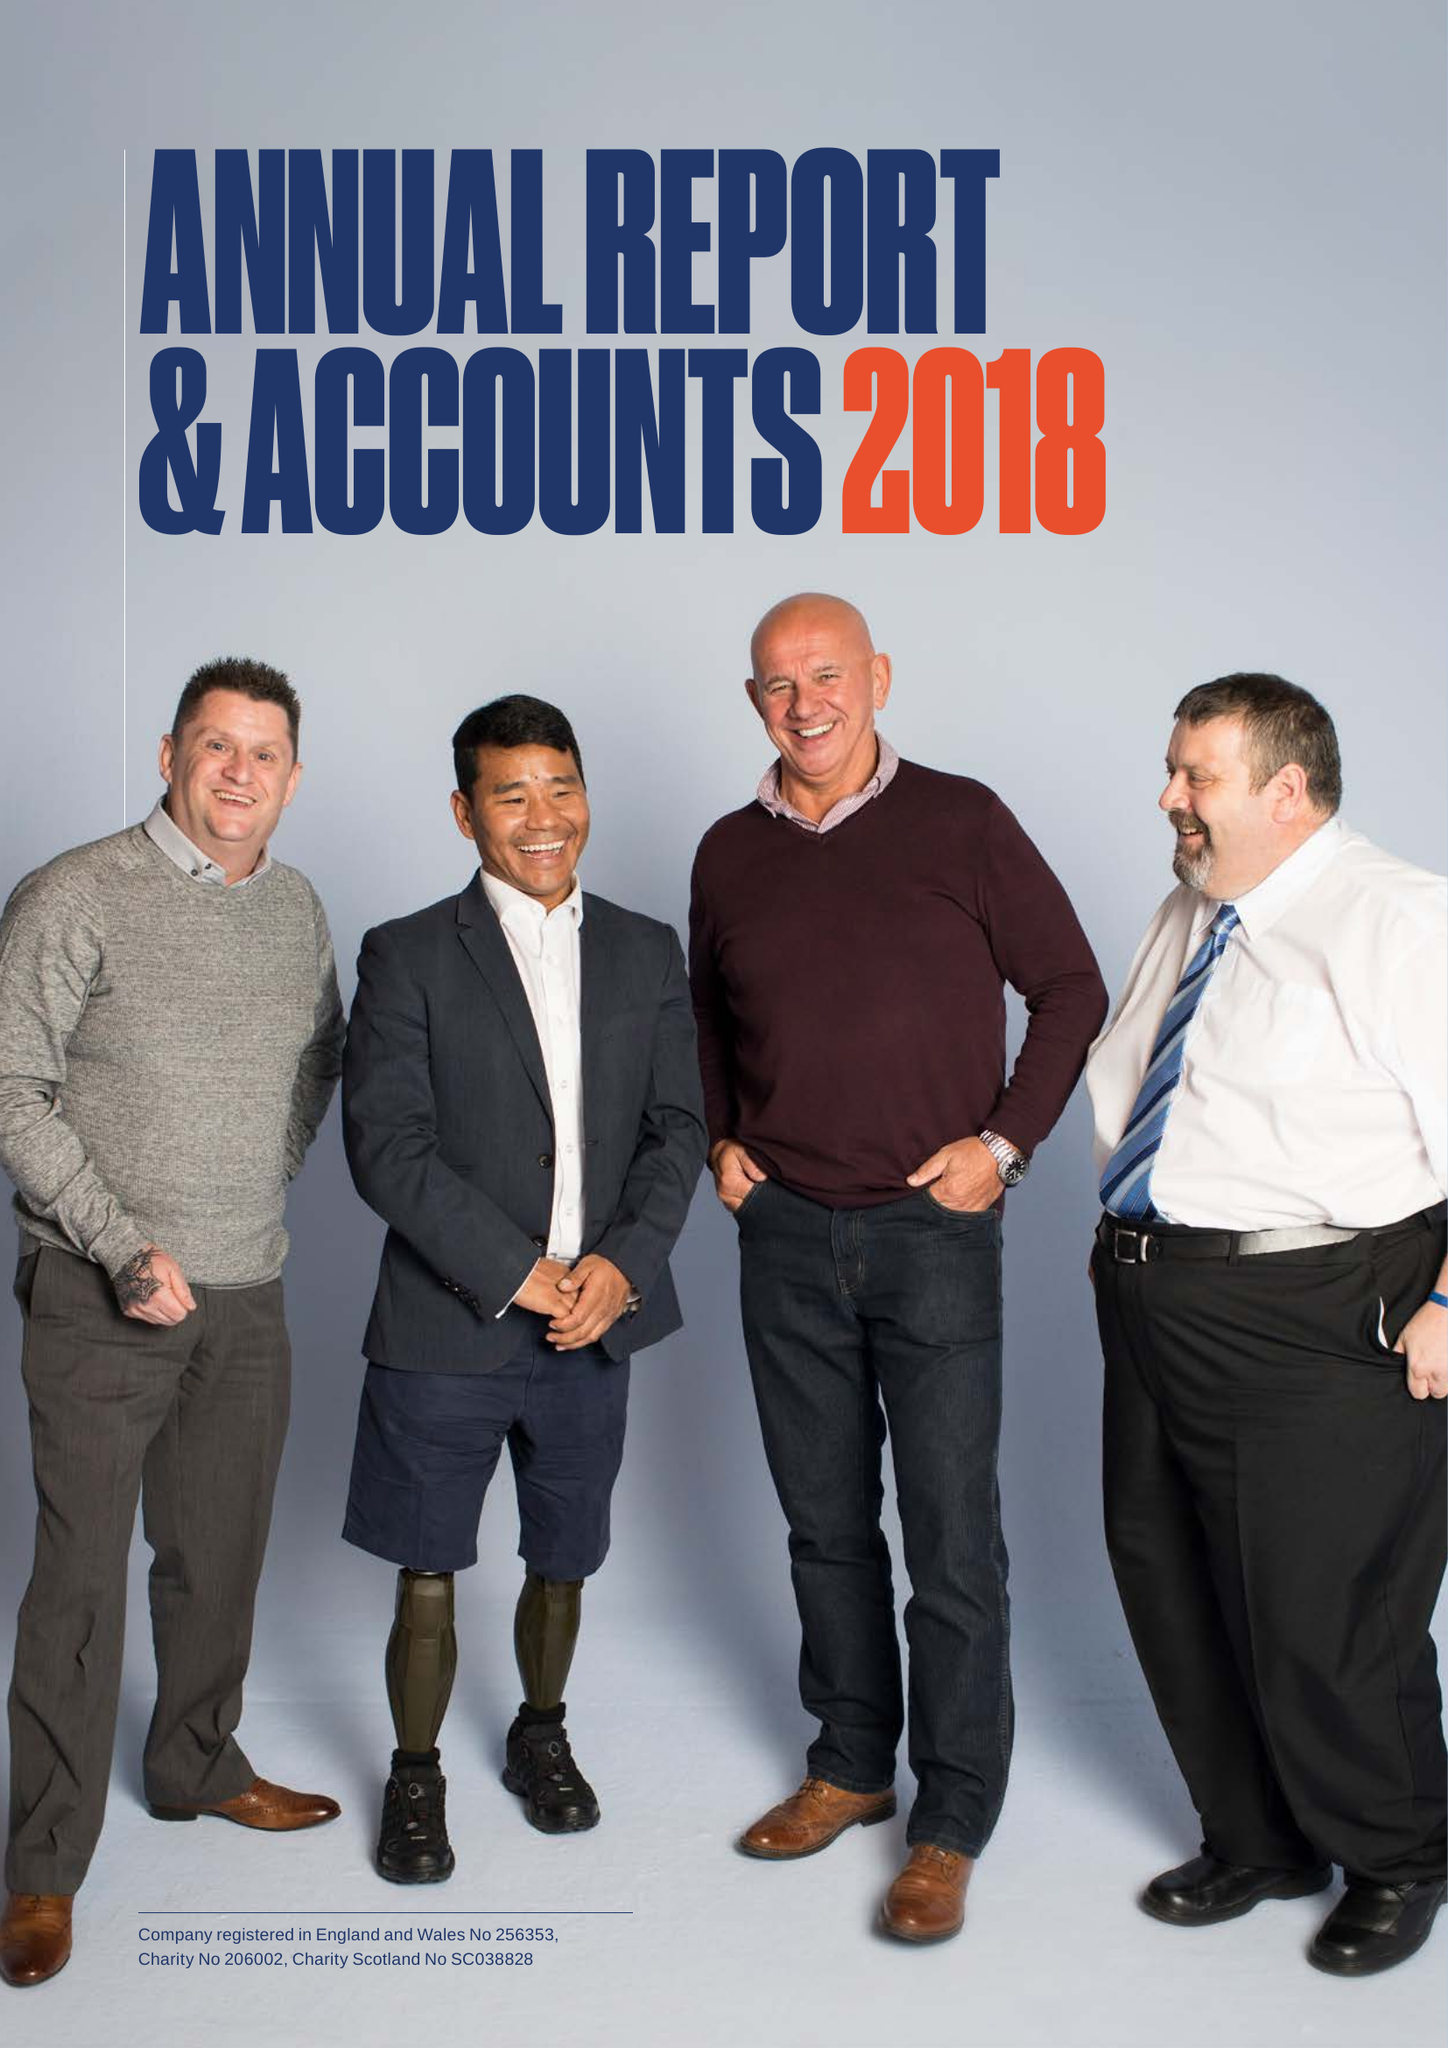What is the value for the spending_annually_in_british_pounds?
Answer the question using a single word or phrase. 15441000.00 